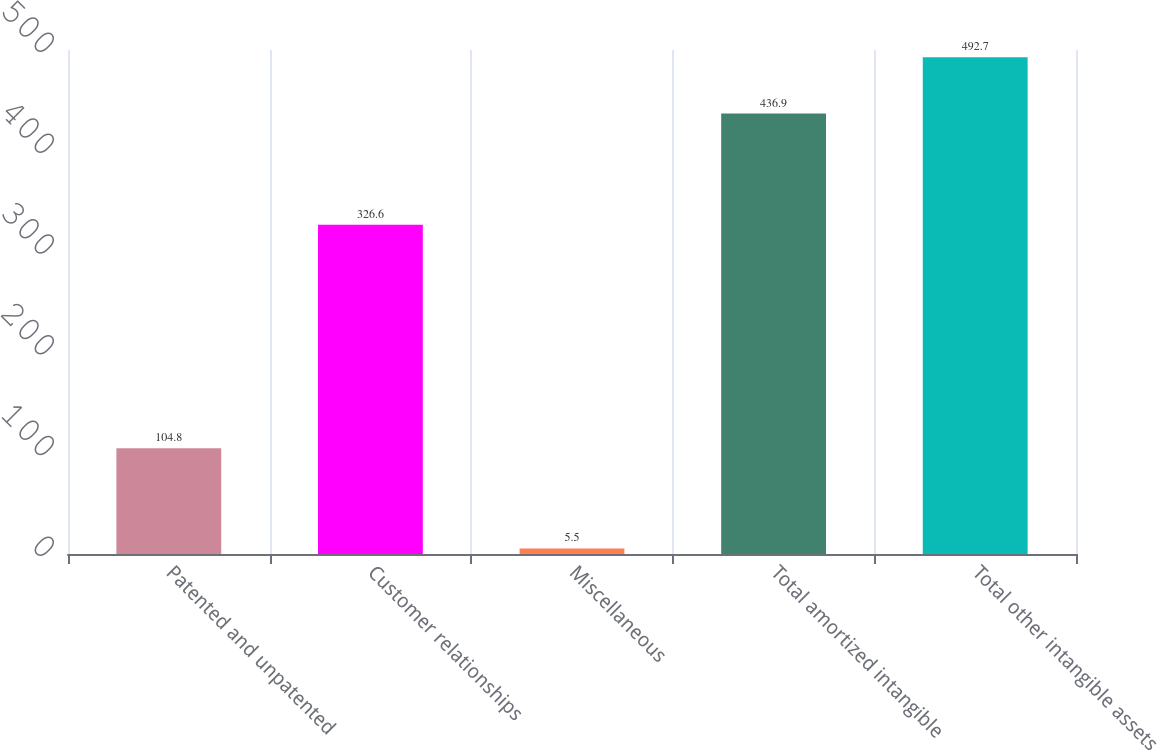Convert chart. <chart><loc_0><loc_0><loc_500><loc_500><bar_chart><fcel>Patented and unpatented<fcel>Customer relationships<fcel>Miscellaneous<fcel>Total amortized intangible<fcel>Total other intangible assets<nl><fcel>104.8<fcel>326.6<fcel>5.5<fcel>436.9<fcel>492.7<nl></chart> 